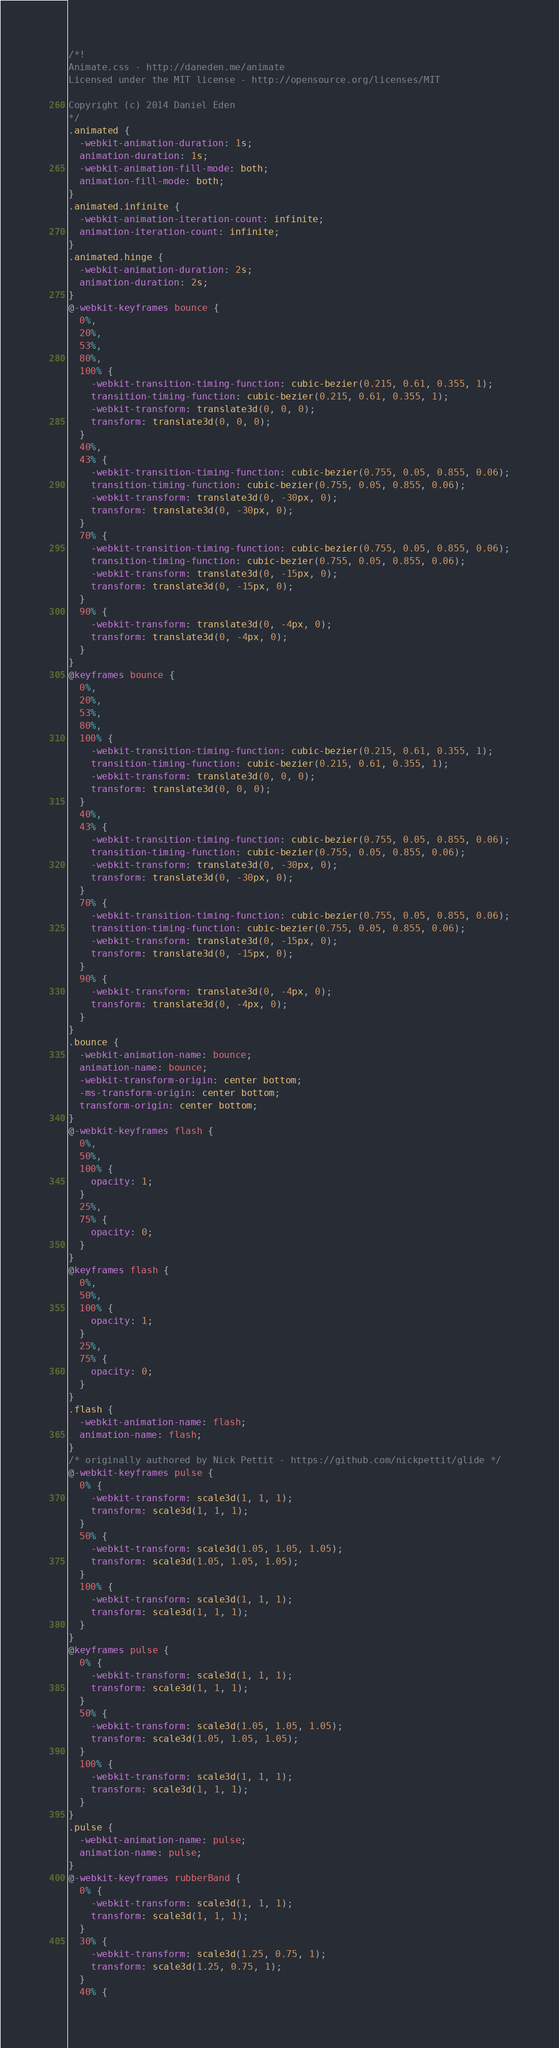<code> <loc_0><loc_0><loc_500><loc_500><_CSS_>/*!
Animate.css - http://daneden.me/animate
Licensed under the MIT license - http://opensource.org/licenses/MIT

Copyright (c) 2014 Daniel Eden
*/
.animated {
  -webkit-animation-duration: 1s;
  animation-duration: 1s;
  -webkit-animation-fill-mode: both;
  animation-fill-mode: both;
}
.animated.infinite {
  -webkit-animation-iteration-count: infinite;
  animation-iteration-count: infinite;
}
.animated.hinge {
  -webkit-animation-duration: 2s;
  animation-duration: 2s;
}
@-webkit-keyframes bounce {
  0%,
  20%,
  53%,
  80%,
  100% {
    -webkit-transition-timing-function: cubic-bezier(0.215, 0.61, 0.355, 1);
    transition-timing-function: cubic-bezier(0.215, 0.61, 0.355, 1);
    -webkit-transform: translate3d(0, 0, 0);
    transform: translate3d(0, 0, 0);
  }
  40%,
  43% {
    -webkit-transition-timing-function: cubic-bezier(0.755, 0.05, 0.855, 0.06);
    transition-timing-function: cubic-bezier(0.755, 0.05, 0.855, 0.06);
    -webkit-transform: translate3d(0, -30px, 0);
    transform: translate3d(0, -30px, 0);
  }
  70% {
    -webkit-transition-timing-function: cubic-bezier(0.755, 0.05, 0.855, 0.06);
    transition-timing-function: cubic-bezier(0.755, 0.05, 0.855, 0.06);
    -webkit-transform: translate3d(0, -15px, 0);
    transform: translate3d(0, -15px, 0);
  }
  90% {
    -webkit-transform: translate3d(0, -4px, 0);
    transform: translate3d(0, -4px, 0);
  }
}
@keyframes bounce {
  0%,
  20%,
  53%,
  80%,
  100% {
    -webkit-transition-timing-function: cubic-bezier(0.215, 0.61, 0.355, 1);
    transition-timing-function: cubic-bezier(0.215, 0.61, 0.355, 1);
    -webkit-transform: translate3d(0, 0, 0);
    transform: translate3d(0, 0, 0);
  }
  40%,
  43% {
    -webkit-transition-timing-function: cubic-bezier(0.755, 0.05, 0.855, 0.06);
    transition-timing-function: cubic-bezier(0.755, 0.05, 0.855, 0.06);
    -webkit-transform: translate3d(0, -30px, 0);
    transform: translate3d(0, -30px, 0);
  }
  70% {
    -webkit-transition-timing-function: cubic-bezier(0.755, 0.05, 0.855, 0.06);
    transition-timing-function: cubic-bezier(0.755, 0.05, 0.855, 0.06);
    -webkit-transform: translate3d(0, -15px, 0);
    transform: translate3d(0, -15px, 0);
  }
  90% {
    -webkit-transform: translate3d(0, -4px, 0);
    transform: translate3d(0, -4px, 0);
  }
}
.bounce {
  -webkit-animation-name: bounce;
  animation-name: bounce;
  -webkit-transform-origin: center bottom;
  -ms-transform-origin: center bottom;
  transform-origin: center bottom;
}
@-webkit-keyframes flash {
  0%,
  50%,
  100% {
    opacity: 1;
  }
  25%,
  75% {
    opacity: 0;
  }
}
@keyframes flash {
  0%,
  50%,
  100% {
    opacity: 1;
  }
  25%,
  75% {
    opacity: 0;
  }
}
.flash {
  -webkit-animation-name: flash;
  animation-name: flash;
}
/* originally authored by Nick Pettit - https://github.com/nickpettit/glide */
@-webkit-keyframes pulse {
  0% {
    -webkit-transform: scale3d(1, 1, 1);
    transform: scale3d(1, 1, 1);
  }
  50% {
    -webkit-transform: scale3d(1.05, 1.05, 1.05);
    transform: scale3d(1.05, 1.05, 1.05);
  }
  100% {
    -webkit-transform: scale3d(1, 1, 1);
    transform: scale3d(1, 1, 1);
  }
}
@keyframes pulse {
  0% {
    -webkit-transform: scale3d(1, 1, 1);
    transform: scale3d(1, 1, 1);
  }
  50% {
    -webkit-transform: scale3d(1.05, 1.05, 1.05);
    transform: scale3d(1.05, 1.05, 1.05);
  }
  100% {
    -webkit-transform: scale3d(1, 1, 1);
    transform: scale3d(1, 1, 1);
  }
}
.pulse {
  -webkit-animation-name: pulse;
  animation-name: pulse;
}
@-webkit-keyframes rubberBand {
  0% {
    -webkit-transform: scale3d(1, 1, 1);
    transform: scale3d(1, 1, 1);
  }
  30% {
    -webkit-transform: scale3d(1.25, 0.75, 1);
    transform: scale3d(1.25, 0.75, 1);
  }
  40% {</code> 